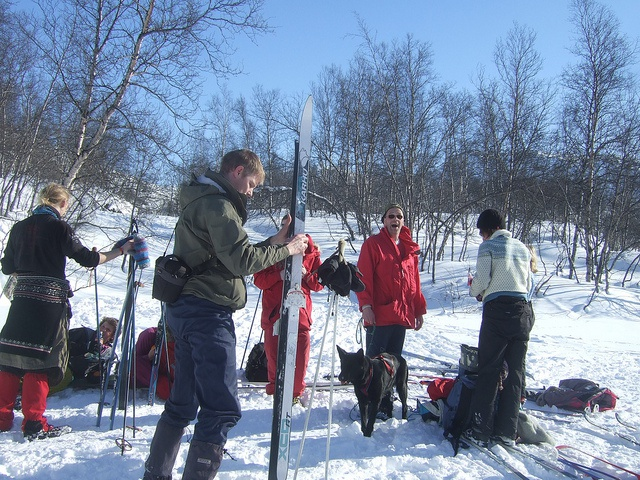Describe the objects in this image and their specific colors. I can see people in gray, black, maroon, and lightgray tones, people in gray, black, and darkblue tones, skis in gray, darkgray, and black tones, dog in gray and black tones, and backpack in gray, black, darkblue, and purple tones in this image. 